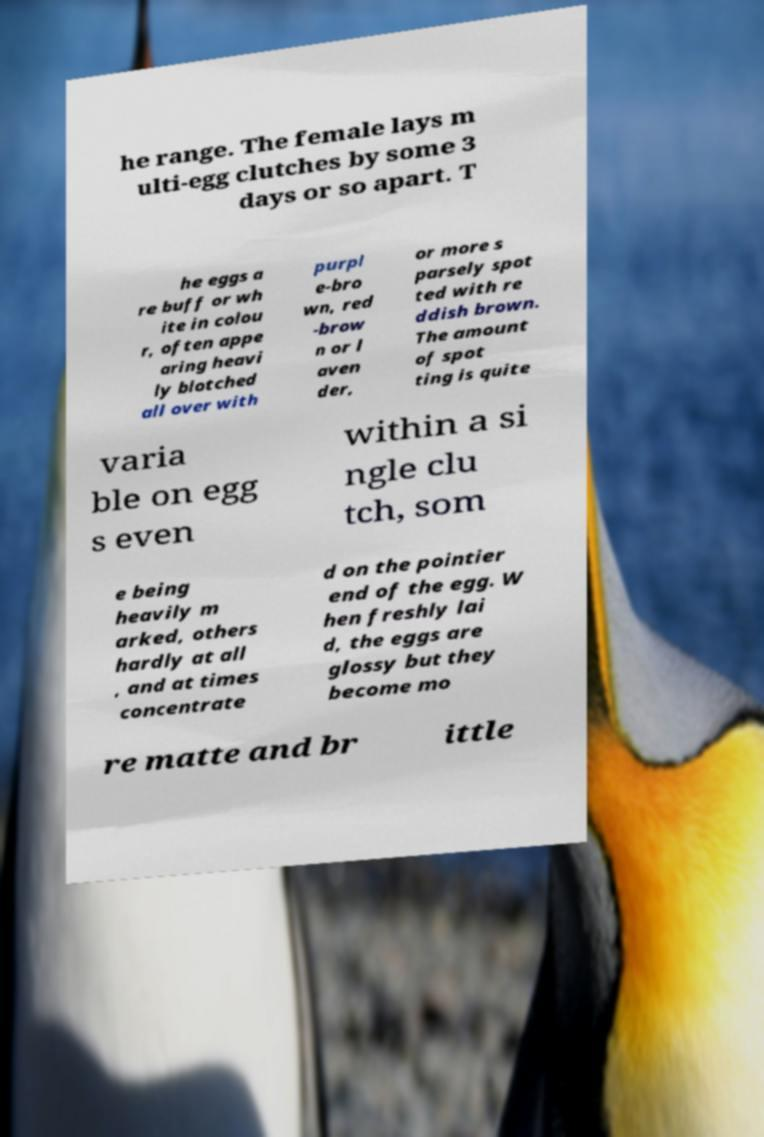For documentation purposes, I need the text within this image transcribed. Could you provide that? he range. The female lays m ulti-egg clutches by some 3 days or so apart. T he eggs a re buff or wh ite in colou r, often appe aring heavi ly blotched all over with purpl e-bro wn, red -brow n or l aven der, or more s parsely spot ted with re ddish brown. The amount of spot ting is quite varia ble on egg s even within a si ngle clu tch, som e being heavily m arked, others hardly at all , and at times concentrate d on the pointier end of the egg. W hen freshly lai d, the eggs are glossy but they become mo re matte and br ittle 